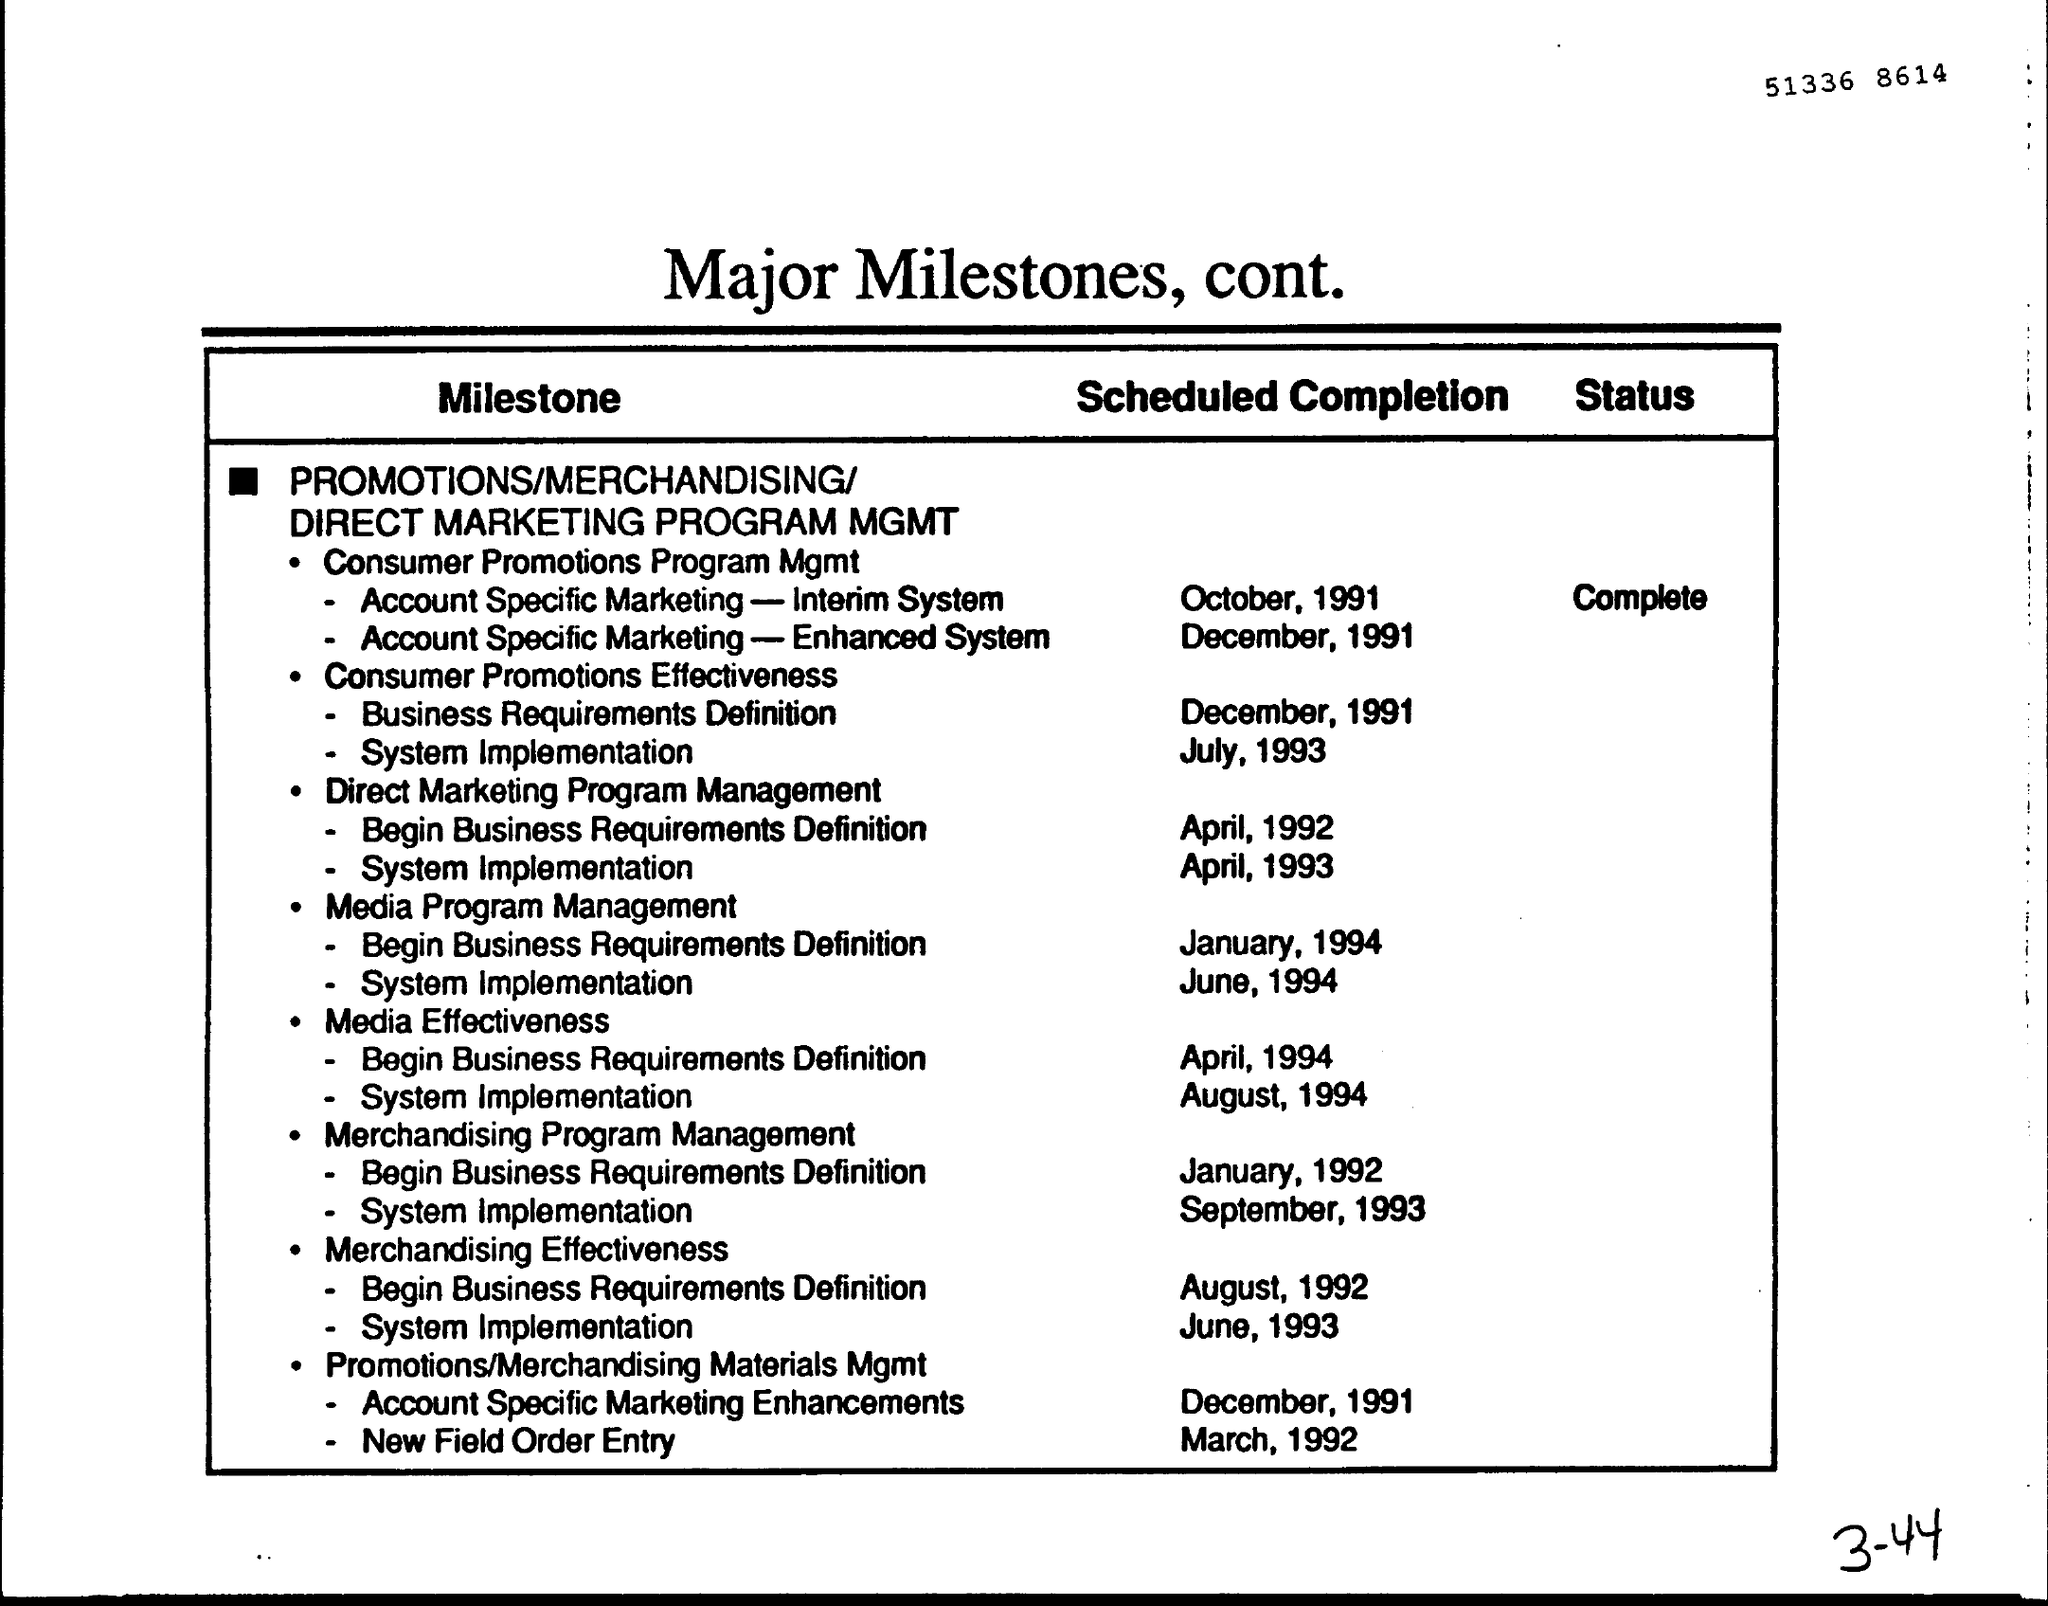Highlight a few significant elements in this photo. The letterhead contains major milestones and further details. 